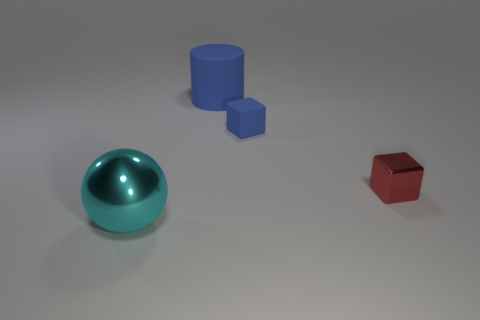There is a large thing in front of the small thing on the left side of the tiny metallic thing; what shape is it?
Make the answer very short. Sphere. What number of other things are there of the same shape as the tiny red metal object?
Your response must be concise. 1. There is a shiny object that is to the right of the large object that is right of the large cyan shiny sphere; what size is it?
Make the answer very short. Small. Are any small red objects visible?
Offer a very short reply. Yes. There is a tiny thing that is left of the shiny block; how many things are on the right side of it?
Make the answer very short. 1. The shiny thing that is behind the large sphere has what shape?
Give a very brief answer. Cube. The blue object that is to the right of the large object behind the metallic object right of the small blue object is made of what material?
Provide a succinct answer. Rubber. What number of other things are the same size as the blue cylinder?
Give a very brief answer. 1. What is the material of the other small blue object that is the same shape as the tiny metal thing?
Your answer should be very brief. Rubber. The large rubber cylinder is what color?
Your answer should be compact. Blue. 